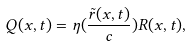<formula> <loc_0><loc_0><loc_500><loc_500>Q ( x , t ) = \eta ( \frac { \tilde { r } ( x , t ) } { c } ) R ( x , t ) ,</formula> 